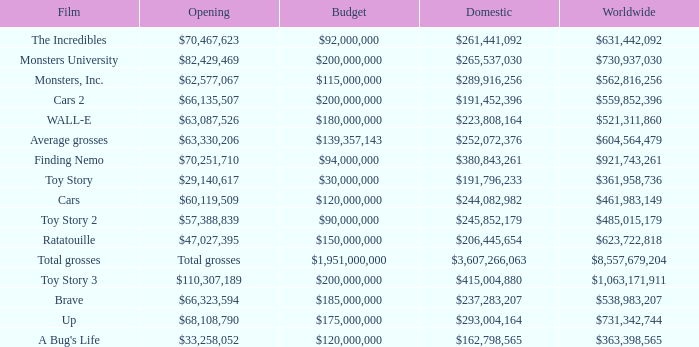WHAT IS THE BUDGET FOR THE INCREDIBLES? $92,000,000. 